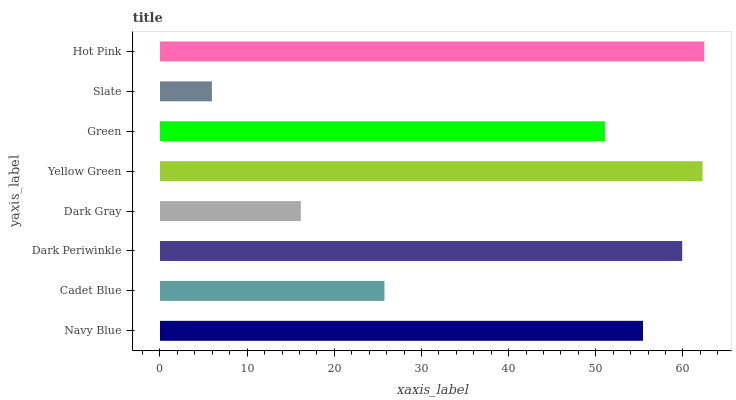Is Slate the minimum?
Answer yes or no. Yes. Is Hot Pink the maximum?
Answer yes or no. Yes. Is Cadet Blue the minimum?
Answer yes or no. No. Is Cadet Blue the maximum?
Answer yes or no. No. Is Navy Blue greater than Cadet Blue?
Answer yes or no. Yes. Is Cadet Blue less than Navy Blue?
Answer yes or no. Yes. Is Cadet Blue greater than Navy Blue?
Answer yes or no. No. Is Navy Blue less than Cadet Blue?
Answer yes or no. No. Is Navy Blue the high median?
Answer yes or no. Yes. Is Green the low median?
Answer yes or no. Yes. Is Dark Gray the high median?
Answer yes or no. No. Is Hot Pink the low median?
Answer yes or no. No. 